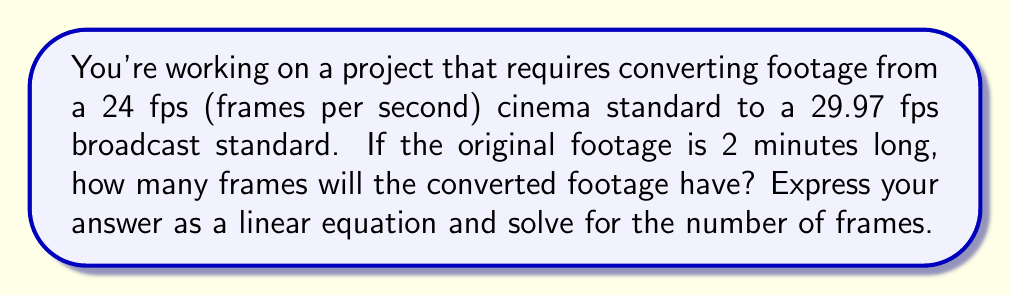Could you help me with this problem? Let's approach this step-by-step:

1) First, we need to calculate the number of frames in the original footage:
   - Duration: 2 minutes = 120 seconds
   - Frame rate: 24 fps
   - Number of frames = $120 \times 24 = 2880$ frames

2) Now, we need to set up a linear equation to convert this to 29.97 fps:
   - Let $x$ be the number of frames in the converted footage
   - The time duration should remain the same for both

3) We can express this as an equation:
   $$\frac{2880}{24} = \frac{x}{29.97}$$

4) Simplify the left side:
   $$120 = \frac{x}{29.97}$$

5) Multiply both sides by 29.97:
   $$120 \times 29.97 = x$$

6) Calculate:
   $$3596.4 = x$$

7) Since we can't have a fractional frame, we round to the nearest whole number:
   $$x = 3596$$ frames

Therefore, the converted footage will have 3596 frames.
Answer: $x = 3596$ frames 